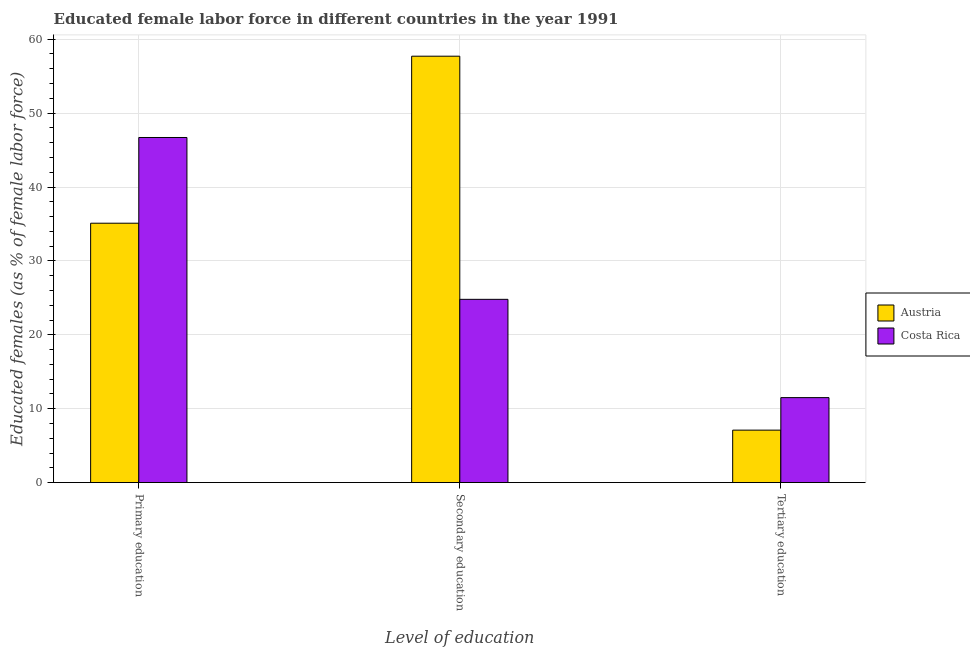How many different coloured bars are there?
Your response must be concise. 2. Are the number of bars on each tick of the X-axis equal?
Your answer should be very brief. Yes. How many bars are there on the 2nd tick from the left?
Keep it short and to the point. 2. How many bars are there on the 2nd tick from the right?
Give a very brief answer. 2. What is the label of the 2nd group of bars from the left?
Give a very brief answer. Secondary education. What is the percentage of female labor force who received primary education in Austria?
Offer a very short reply. 35.1. Across all countries, what is the maximum percentage of female labor force who received tertiary education?
Your answer should be compact. 11.5. Across all countries, what is the minimum percentage of female labor force who received secondary education?
Ensure brevity in your answer.  24.8. What is the total percentage of female labor force who received secondary education in the graph?
Keep it short and to the point. 82.5. What is the difference between the percentage of female labor force who received primary education in Austria and that in Costa Rica?
Your answer should be very brief. -11.6. What is the difference between the percentage of female labor force who received secondary education in Costa Rica and the percentage of female labor force who received primary education in Austria?
Ensure brevity in your answer.  -10.3. What is the average percentage of female labor force who received tertiary education per country?
Keep it short and to the point. 9.3. What is the difference between the percentage of female labor force who received primary education and percentage of female labor force who received secondary education in Austria?
Offer a very short reply. -22.6. What is the ratio of the percentage of female labor force who received primary education in Costa Rica to that in Austria?
Your response must be concise. 1.33. Is the difference between the percentage of female labor force who received secondary education in Austria and Costa Rica greater than the difference between the percentage of female labor force who received tertiary education in Austria and Costa Rica?
Your answer should be very brief. Yes. What is the difference between the highest and the second highest percentage of female labor force who received primary education?
Provide a short and direct response. 11.6. What is the difference between the highest and the lowest percentage of female labor force who received secondary education?
Provide a succinct answer. 32.9. In how many countries, is the percentage of female labor force who received tertiary education greater than the average percentage of female labor force who received tertiary education taken over all countries?
Ensure brevity in your answer.  1. What does the 2nd bar from the left in Secondary education represents?
Make the answer very short. Costa Rica. What does the 1st bar from the right in Primary education represents?
Ensure brevity in your answer.  Costa Rica. Is it the case that in every country, the sum of the percentage of female labor force who received primary education and percentage of female labor force who received secondary education is greater than the percentage of female labor force who received tertiary education?
Make the answer very short. Yes. Are all the bars in the graph horizontal?
Ensure brevity in your answer.  No. How many countries are there in the graph?
Provide a short and direct response. 2. How are the legend labels stacked?
Provide a succinct answer. Vertical. What is the title of the graph?
Provide a succinct answer. Educated female labor force in different countries in the year 1991. Does "United Kingdom" appear as one of the legend labels in the graph?
Ensure brevity in your answer.  No. What is the label or title of the X-axis?
Give a very brief answer. Level of education. What is the label or title of the Y-axis?
Keep it short and to the point. Educated females (as % of female labor force). What is the Educated females (as % of female labor force) of Austria in Primary education?
Your answer should be very brief. 35.1. What is the Educated females (as % of female labor force) in Costa Rica in Primary education?
Offer a terse response. 46.7. What is the Educated females (as % of female labor force) in Austria in Secondary education?
Your answer should be compact. 57.7. What is the Educated females (as % of female labor force) of Costa Rica in Secondary education?
Offer a terse response. 24.8. What is the Educated females (as % of female labor force) of Austria in Tertiary education?
Provide a succinct answer. 7.1. What is the Educated females (as % of female labor force) in Costa Rica in Tertiary education?
Provide a succinct answer. 11.5. Across all Level of education, what is the maximum Educated females (as % of female labor force) in Austria?
Your answer should be compact. 57.7. Across all Level of education, what is the maximum Educated females (as % of female labor force) in Costa Rica?
Your response must be concise. 46.7. Across all Level of education, what is the minimum Educated females (as % of female labor force) of Austria?
Provide a succinct answer. 7.1. What is the total Educated females (as % of female labor force) of Austria in the graph?
Your response must be concise. 99.9. What is the difference between the Educated females (as % of female labor force) in Austria in Primary education and that in Secondary education?
Provide a short and direct response. -22.6. What is the difference between the Educated females (as % of female labor force) of Costa Rica in Primary education and that in Secondary education?
Offer a terse response. 21.9. What is the difference between the Educated females (as % of female labor force) of Costa Rica in Primary education and that in Tertiary education?
Your response must be concise. 35.2. What is the difference between the Educated females (as % of female labor force) of Austria in Secondary education and that in Tertiary education?
Your answer should be compact. 50.6. What is the difference between the Educated females (as % of female labor force) of Austria in Primary education and the Educated females (as % of female labor force) of Costa Rica in Secondary education?
Your answer should be very brief. 10.3. What is the difference between the Educated females (as % of female labor force) of Austria in Primary education and the Educated females (as % of female labor force) of Costa Rica in Tertiary education?
Keep it short and to the point. 23.6. What is the difference between the Educated females (as % of female labor force) in Austria in Secondary education and the Educated females (as % of female labor force) in Costa Rica in Tertiary education?
Your response must be concise. 46.2. What is the average Educated females (as % of female labor force) of Austria per Level of education?
Make the answer very short. 33.3. What is the average Educated females (as % of female labor force) of Costa Rica per Level of education?
Your answer should be compact. 27.67. What is the difference between the Educated females (as % of female labor force) of Austria and Educated females (as % of female labor force) of Costa Rica in Secondary education?
Provide a short and direct response. 32.9. What is the difference between the Educated females (as % of female labor force) of Austria and Educated females (as % of female labor force) of Costa Rica in Tertiary education?
Provide a short and direct response. -4.4. What is the ratio of the Educated females (as % of female labor force) of Austria in Primary education to that in Secondary education?
Ensure brevity in your answer.  0.61. What is the ratio of the Educated females (as % of female labor force) in Costa Rica in Primary education to that in Secondary education?
Make the answer very short. 1.88. What is the ratio of the Educated females (as % of female labor force) in Austria in Primary education to that in Tertiary education?
Your answer should be compact. 4.94. What is the ratio of the Educated females (as % of female labor force) of Costa Rica in Primary education to that in Tertiary education?
Your response must be concise. 4.06. What is the ratio of the Educated females (as % of female labor force) of Austria in Secondary education to that in Tertiary education?
Give a very brief answer. 8.13. What is the ratio of the Educated females (as % of female labor force) in Costa Rica in Secondary education to that in Tertiary education?
Your answer should be very brief. 2.16. What is the difference between the highest and the second highest Educated females (as % of female labor force) of Austria?
Offer a terse response. 22.6. What is the difference between the highest and the second highest Educated females (as % of female labor force) of Costa Rica?
Your answer should be very brief. 21.9. What is the difference between the highest and the lowest Educated females (as % of female labor force) in Austria?
Your answer should be very brief. 50.6. What is the difference between the highest and the lowest Educated females (as % of female labor force) in Costa Rica?
Make the answer very short. 35.2. 